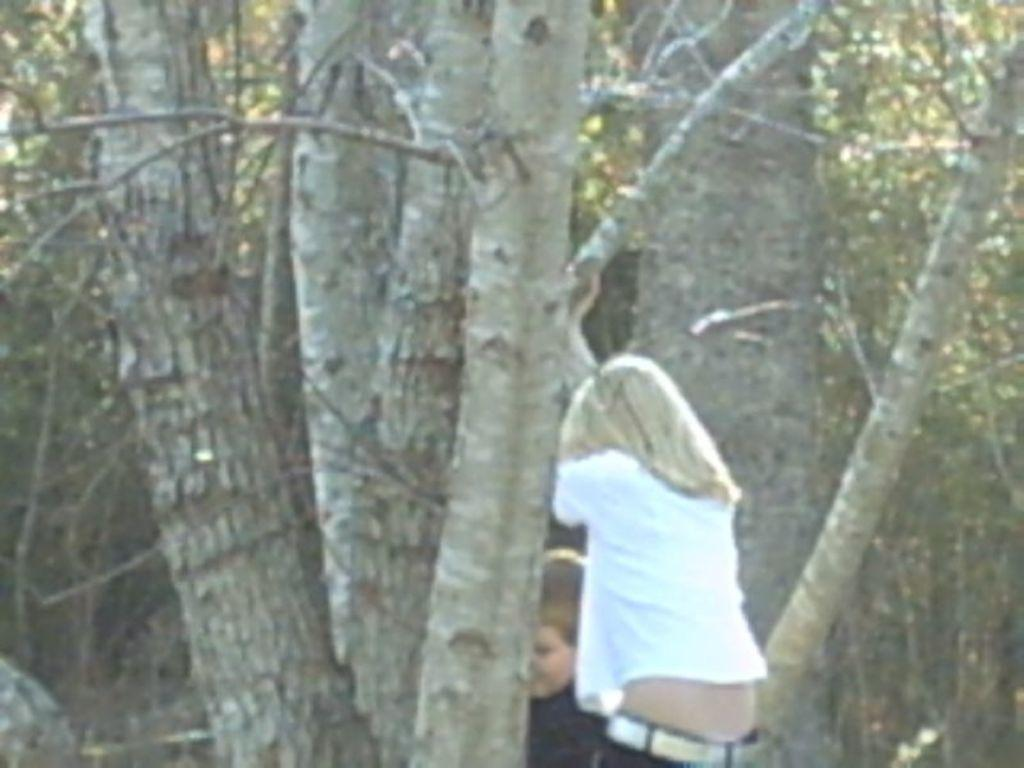What type of vegetation can be seen in the image? There are trees in the image. How many people are present in the image? There are two persons in the image. What type of insurance policy do the trees in the image have? There is no information about insurance policies in the image, as it only features trees and two persons. What is the aftermath of the event involving the two persons in the image? There is no event or aftermath mentioned in the image; it simply shows two persons and trees. 